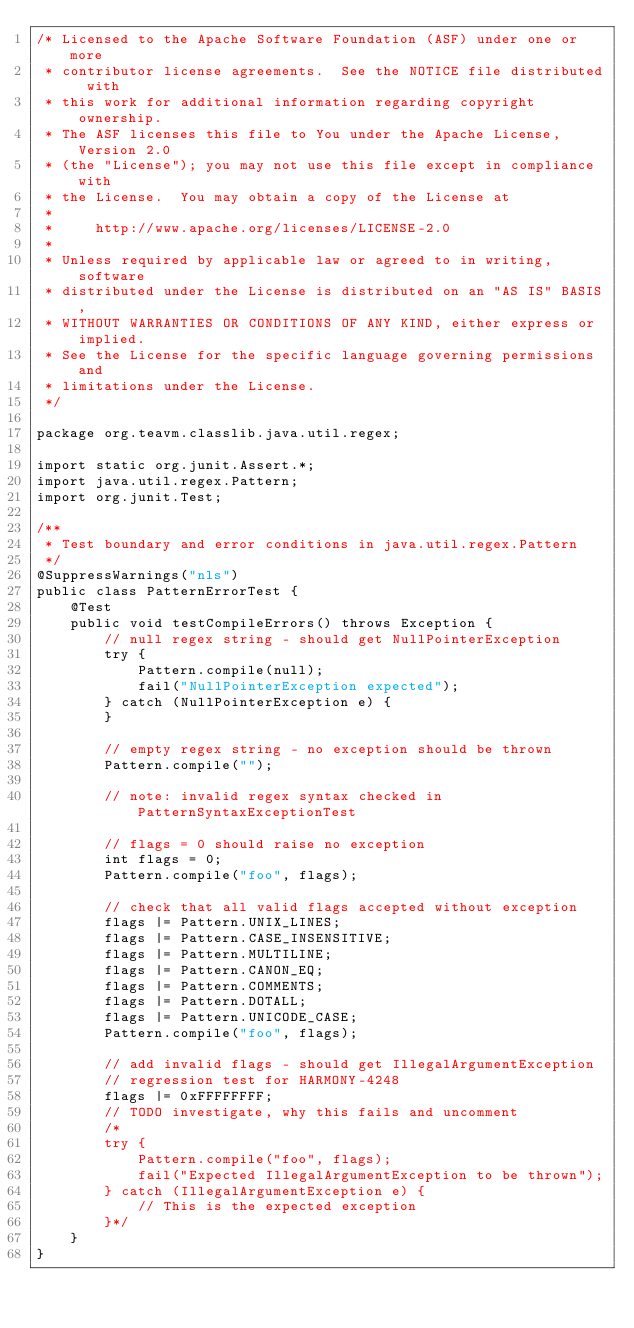Convert code to text. <code><loc_0><loc_0><loc_500><loc_500><_Java_>/* Licensed to the Apache Software Foundation (ASF) under one or more
 * contributor license agreements.  See the NOTICE file distributed with
 * this work for additional information regarding copyright ownership.
 * The ASF licenses this file to You under the Apache License, Version 2.0
 * (the "License"); you may not use this file except in compliance with
 * the License.  You may obtain a copy of the License at
 *
 *     http://www.apache.org/licenses/LICENSE-2.0
 *
 * Unless required by applicable law or agreed to in writing, software
 * distributed under the License is distributed on an "AS IS" BASIS,
 * WITHOUT WARRANTIES OR CONDITIONS OF ANY KIND, either express or implied.
 * See the License for the specific language governing permissions and
 * limitations under the License.
 */

package org.teavm.classlib.java.util.regex;

import static org.junit.Assert.*;
import java.util.regex.Pattern;
import org.junit.Test;

/**
 * Test boundary and error conditions in java.util.regex.Pattern
 */
@SuppressWarnings("nls")
public class PatternErrorTest {
    @Test
    public void testCompileErrors() throws Exception {
        // null regex string - should get NullPointerException
        try {
            Pattern.compile(null);
            fail("NullPointerException expected");
        } catch (NullPointerException e) {
        }

        // empty regex string - no exception should be thrown
        Pattern.compile("");

        // note: invalid regex syntax checked in PatternSyntaxExceptionTest

        // flags = 0 should raise no exception
        int flags = 0;
        Pattern.compile("foo", flags);

        // check that all valid flags accepted without exception
        flags |= Pattern.UNIX_LINES;
        flags |= Pattern.CASE_INSENSITIVE;
        flags |= Pattern.MULTILINE;
        flags |= Pattern.CANON_EQ;
        flags |= Pattern.COMMENTS;
        flags |= Pattern.DOTALL;
        flags |= Pattern.UNICODE_CASE;
        Pattern.compile("foo", flags);

        // add invalid flags - should get IllegalArgumentException
        // regression test for HARMONY-4248
        flags |= 0xFFFFFFFF;
        // TODO investigate, why this fails and uncomment
        /*
        try {
            Pattern.compile("foo", flags);
            fail("Expected IllegalArgumentException to be thrown");
        } catch (IllegalArgumentException e) {
            // This is the expected exception
        }*/
    }
}
</code> 